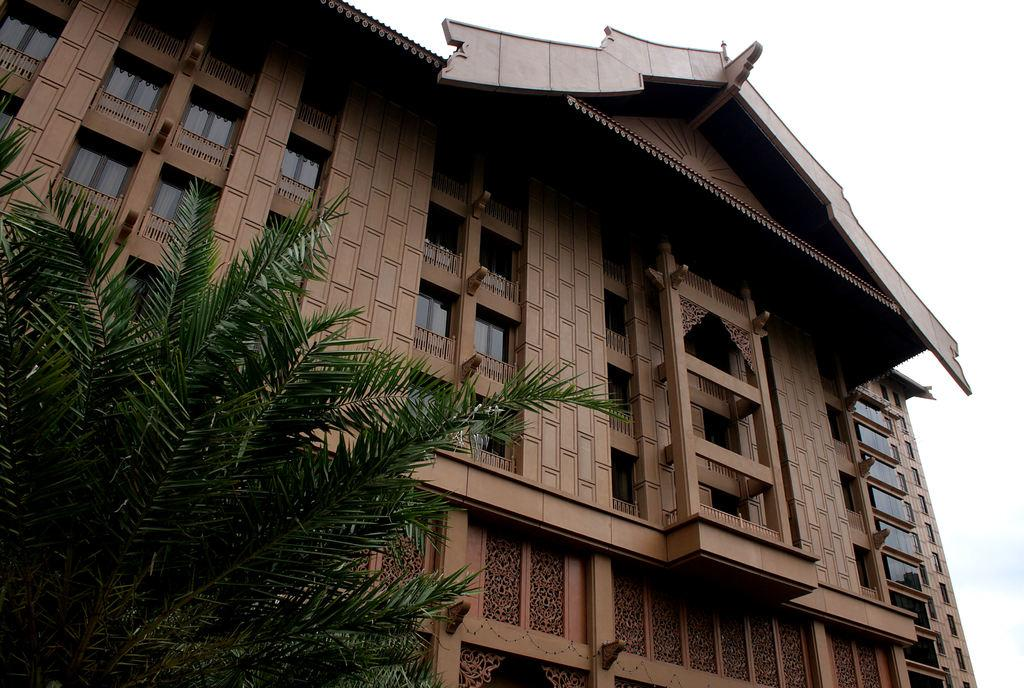What is located on the left side of the image? There is a tree on the left side of the image. What can be seen in the background of the image? There is a building and the sky visible in the background of the image. What type of hole can be seen in the aftermath of the event in the image? There is no event or hole present in the image; it features a tree and a background with a building and the sky. 